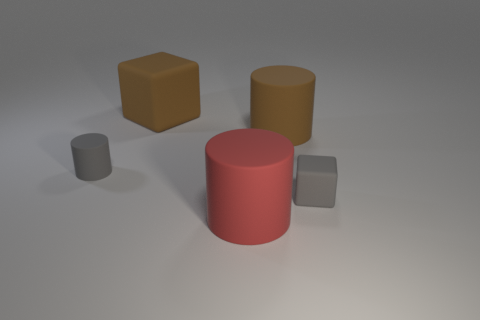How many large brown matte blocks are on the right side of the cube that is in front of the small gray matte thing that is to the left of the small matte block?
Offer a very short reply. 0. How many matte things are small gray cubes or small cylinders?
Your response must be concise. 2. There is a matte block that is on the left side of the large cylinder that is in front of the small cylinder; what is its size?
Your response must be concise. Large. There is a tiny thing right of the big red rubber object; does it have the same color as the cylinder left of the big red rubber object?
Your answer should be compact. Yes. What color is the big matte thing that is both behind the small cylinder and in front of the large rubber block?
Provide a succinct answer. Brown. How many tiny things are either red shiny cylinders or rubber objects?
Make the answer very short. 2. What color is the tiny cube that is made of the same material as the red cylinder?
Your response must be concise. Gray. What is the color of the matte block that is behind the gray cylinder?
Make the answer very short. Brown. What number of rubber cylinders have the same color as the tiny rubber cube?
Your answer should be very brief. 1. Is the number of tiny gray things that are in front of the tiny gray matte cylinder less than the number of large rubber objects left of the large brown cylinder?
Your answer should be compact. Yes. 